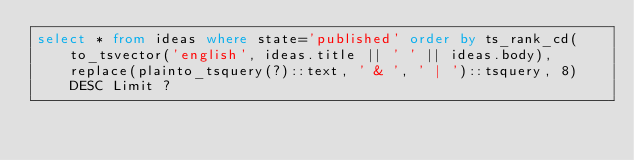<code> <loc_0><loc_0><loc_500><loc_500><_SQL_>select * from ideas where state='published' order by ts_rank_cd(to_tsvector('english', ideas.title || ' ' || ideas.body), replace(plainto_tsquery(?)::text, ' & ', ' | ')::tsquery, 8) DESC Limit ? 
</code> 